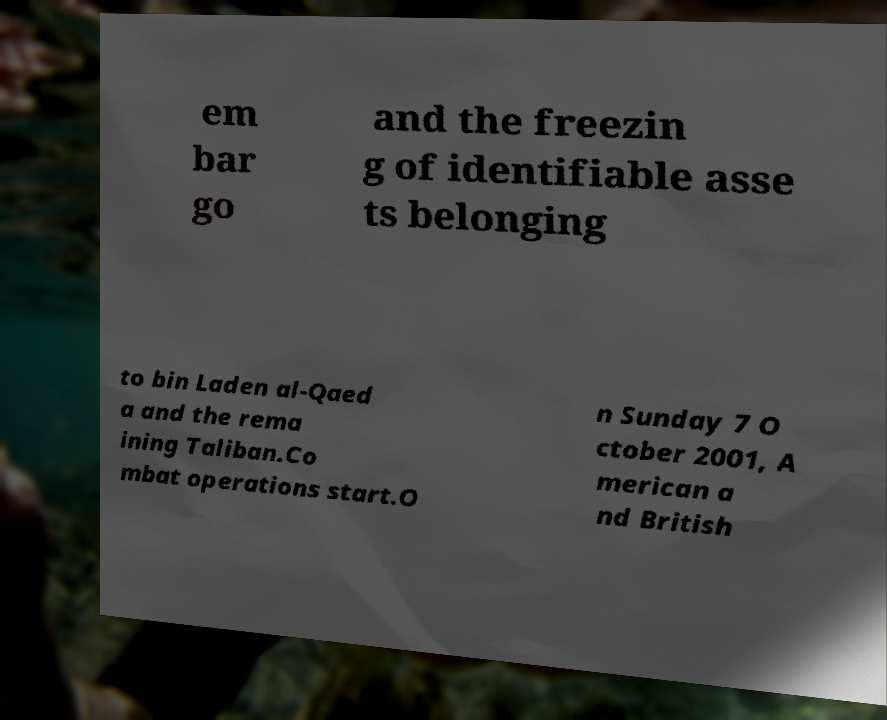Could you extract and type out the text from this image? em bar go and the freezin g of identifiable asse ts belonging to bin Laden al-Qaed a and the rema ining Taliban.Co mbat operations start.O n Sunday 7 O ctober 2001, A merican a nd British 